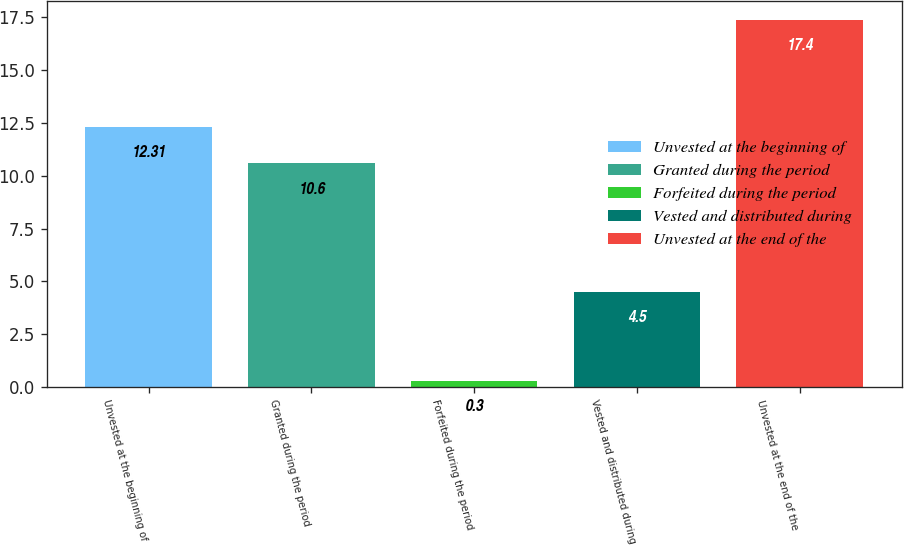Convert chart to OTSL. <chart><loc_0><loc_0><loc_500><loc_500><bar_chart><fcel>Unvested at the beginning of<fcel>Granted during the period<fcel>Forfeited during the period<fcel>Vested and distributed during<fcel>Unvested at the end of the<nl><fcel>12.31<fcel>10.6<fcel>0.3<fcel>4.5<fcel>17.4<nl></chart> 